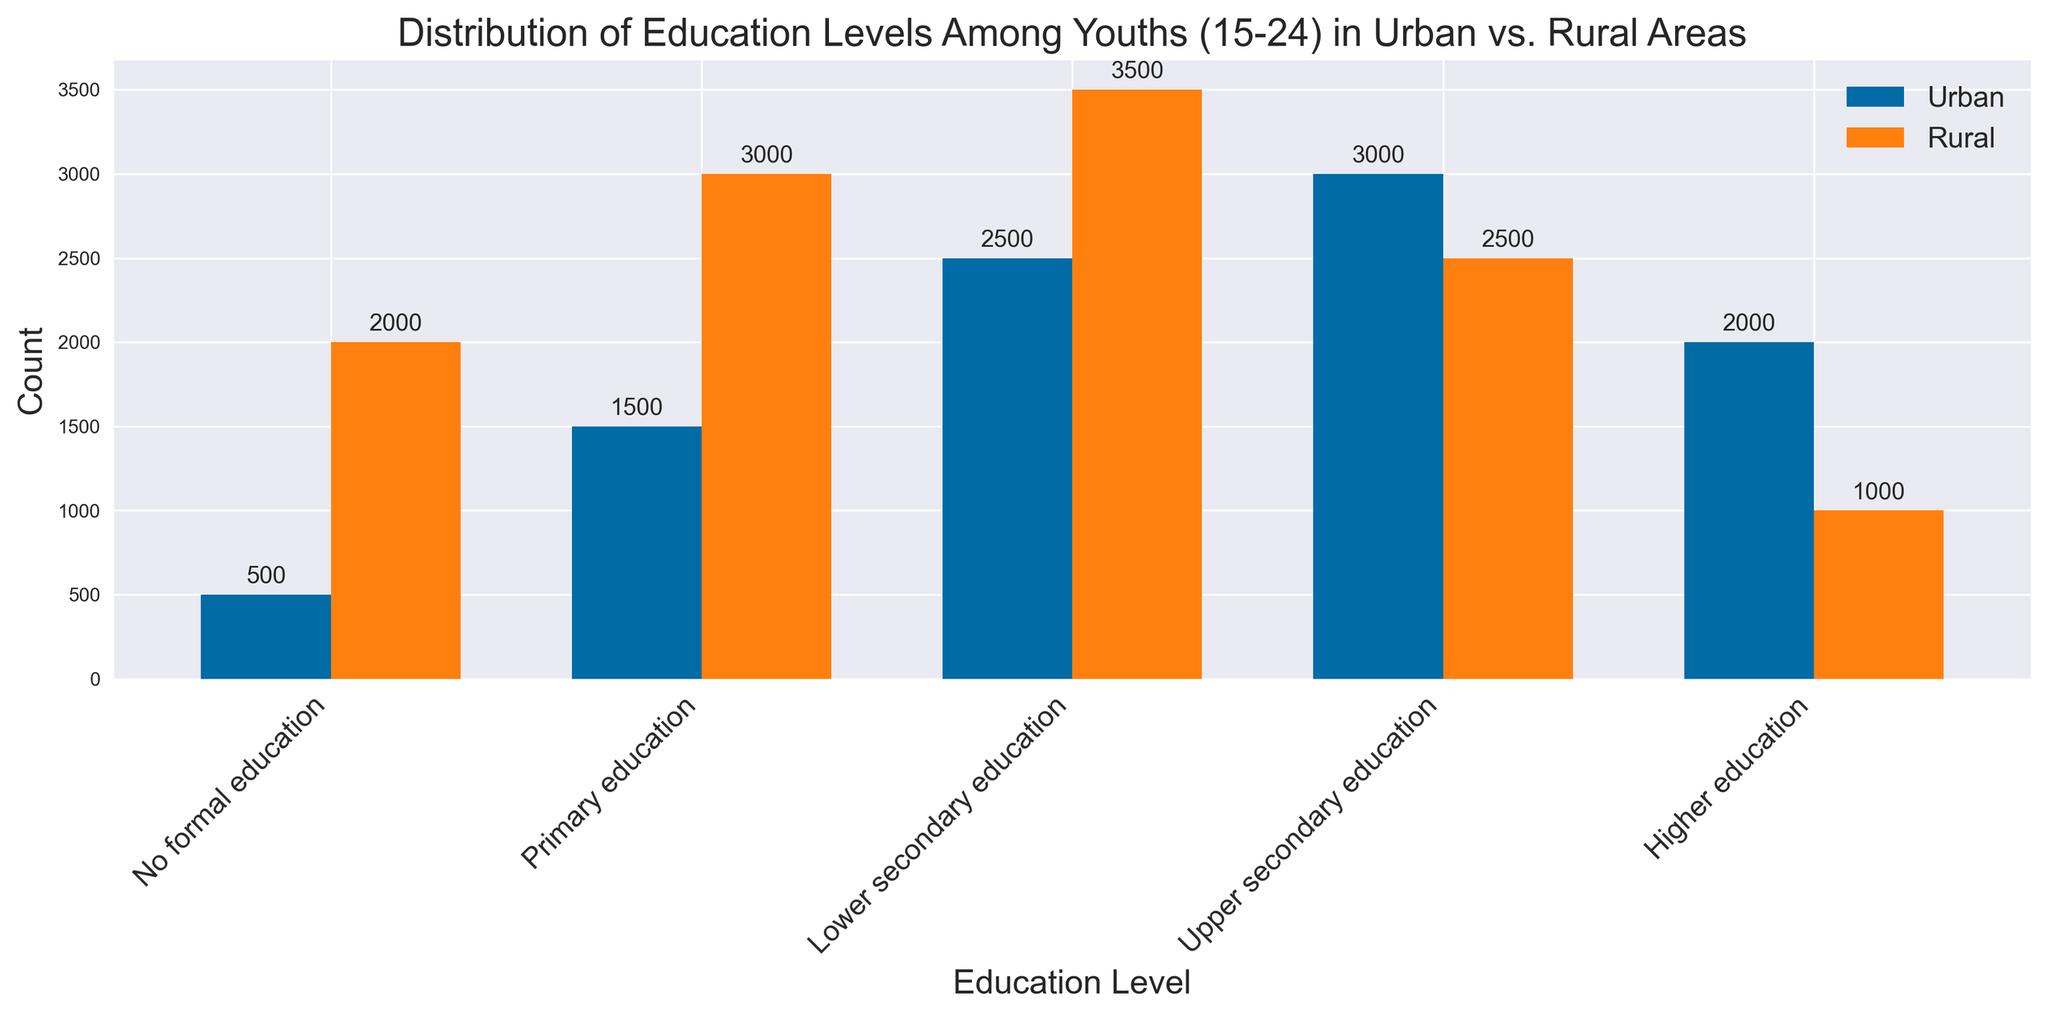Which education level has the highest count in urban areas? To find the education level with the highest count in urban areas, look for the tallest bar among the urban categories. The longest bar corresponds to "Upper secondary education".
Answer: Upper secondary education Which education level has the lowest count in rural areas? To determine the lowest count in rural areas, find the shortest bar among the rural categories. The shortest bar corresponds to "Higher education".
Answer: Higher education What is the combined count for youths with "No formal education" in both urban and rural areas? Sum the counts for "No formal education" in urban (500) and rural (2000) areas. So, 500 + 2000 = 2500.
Answer: 2500 Which region has a higher count for "Primary education" and by how much? Compare the counts for "Primary education" in urban (1500) and rural (3000) areas. The rural count is higher. Subtract the urban count from the rural count (3000 - 1500 = 1500).
Answer: Rural, 1500 Which education level shows the largest difference in counts between urban and rural areas? Calculate the differences for each education level: "No formal education" (2000 - 500 = 1500), "Primary education" (3000 - 1500 = 1500), "Lower secondary education" (3500 - 2500 = 1000), "Upper secondary education" (3000 - 2500 = 500), "Higher education" (2000 - 1000 = 1000). The largest difference is 1500 for both "No formal education" and "Primary education".
Answer: No formal education and Primary education Are there any education levels where the count is equal for both urban and rural areas? Check each education level and compare the counts for urban and rural areas: they are different for all levels.
Answer: No Which education level has the highest count across both regions combined? Add the counts for each education level across both regions: 
"No formal education" (500 + 2000 = 2500), 
"Primary education" (1500 + 3000 = 4500), 
"Lower secondary education" (2500 + 3500 = 6000), 
"Upper secondary education" (3000 + 2500 = 5500), 
"Higher education" (2000 + 1000 = 3000). 
The highest combined count is "Lower secondary education" with 6000.
Answer: Lower secondary education What is the total count of youths represented in the figure? Sum all the counts from both urban and rural areas: 500 + 1500 + 2500 + 3000 + 2000 (urban) and 2000 + 3000 + 3500 + 2500 + 1000 (rural). This equals 9500 (urban) + 12000 (rural) = 21500.
Answer: 21500 